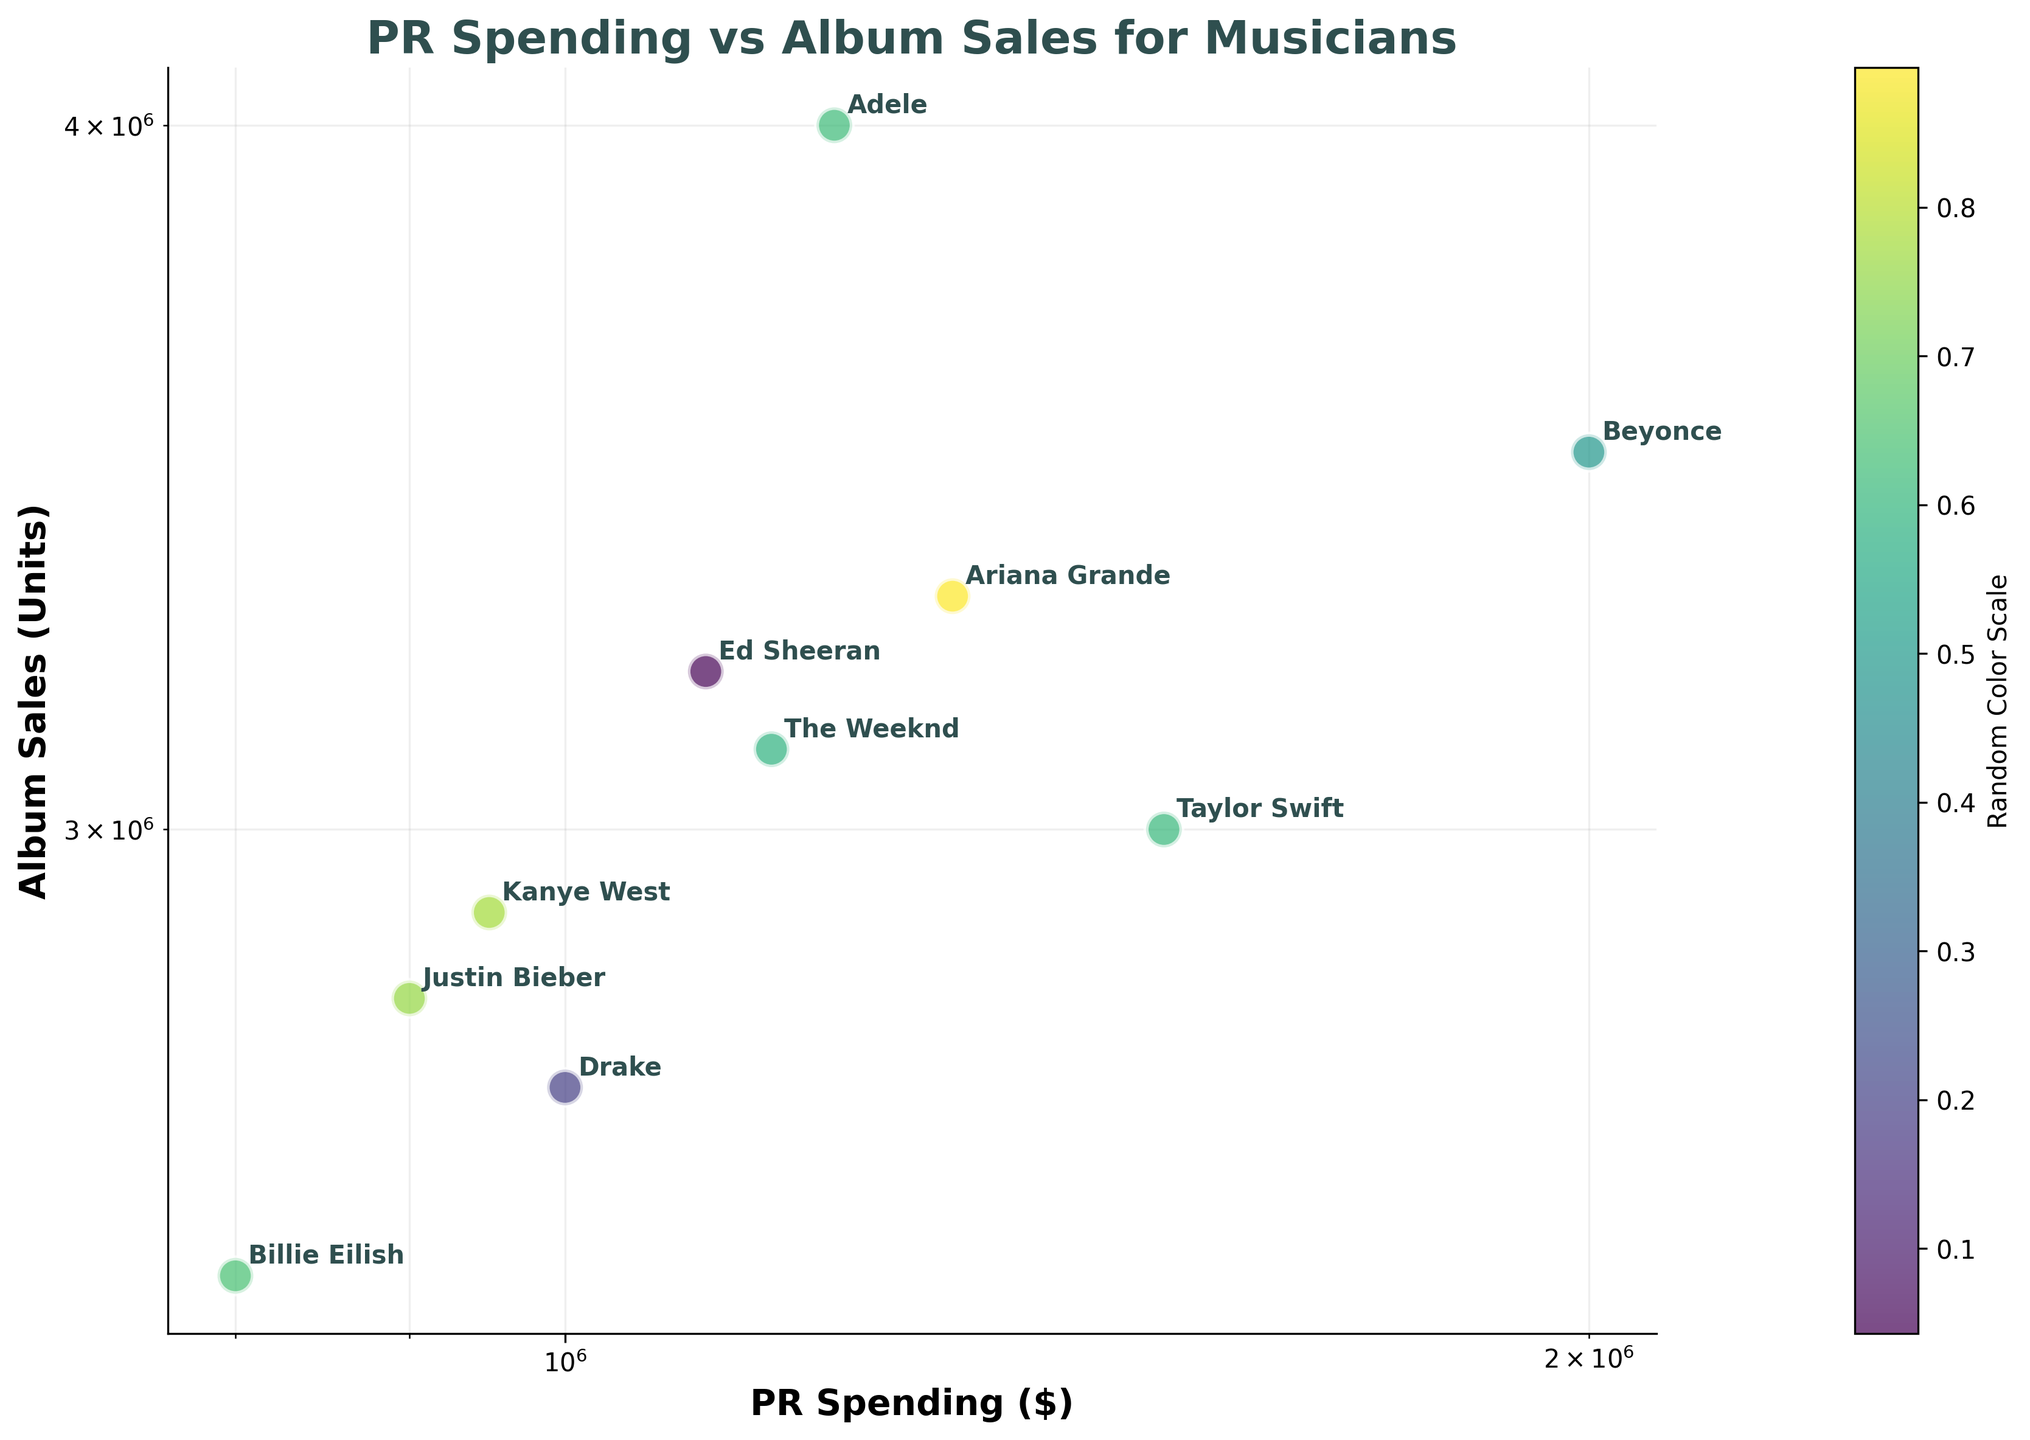What's the title of the figure? The title of the figure is displayed at the top and reads "PR Spending vs Album Sales for Musicians".
Answer: PR Spending vs Album Sales for Musicians What are the labels on the x and y axes? The x-axis label is "PR Spending ($)" and the y-axis label is "Album Sales (Units)".
Answer: PR Spending ($) and Album Sales (Units) How many artists are shown in the scatter plot? Count the number of data points (or annotations of artist names) in the plot. There are 10 artists shown.
Answer: 10 Which artist spent the most on PR? Refer to the data points along the x-axis (log scale) to identify the highest value. Beyonce spent the most on PR.
Answer: Beyonce Which artist had the highest album sales? Check the y-axis (log scale) for the highest album sales value. Adele had the highest album sales.
Answer: Adele What is the relationship between PR Spending and Album Sales for the musicians in the plot? To understand the relationship, observe the trend line formed by the data points. Generally, as PR Spending increases, Album Sales also increase, indicating a positive correlation.
Answer: Positive correlation How does Taylor Swift's PR spending compare to that of Billie Eilish? Locate both artists' data points on the x-axis. Taylor Swift's PR spending ($1,500,000) is significantly higher than Billie Eilish's ($800,000).
Answer: Taylor Swift spends more Which two artists have the closest PR spending? Look for two data points on the x-axis that are nearest to each other. Ed Sheeran ($1,100,000) and The Weeknd ($1,150,000) have the closest PR spending.
Answer: Ed Sheeran and The Weeknd What is the total album sales of Drake and Justin Bieber combined? Add Drake's album sales (2,700,000) and Justin Bieber's album sales (2,800,000) together. The result is 5,500,000.
Answer: 5,500,000 Is there an artist whose album sales are higher than Adele's but spent less on PR? Check Adele's PR spending ($1,200,000) and album sales (4,000,000), and compare with other artists. There is no such artist in the plot.
Answer: No 